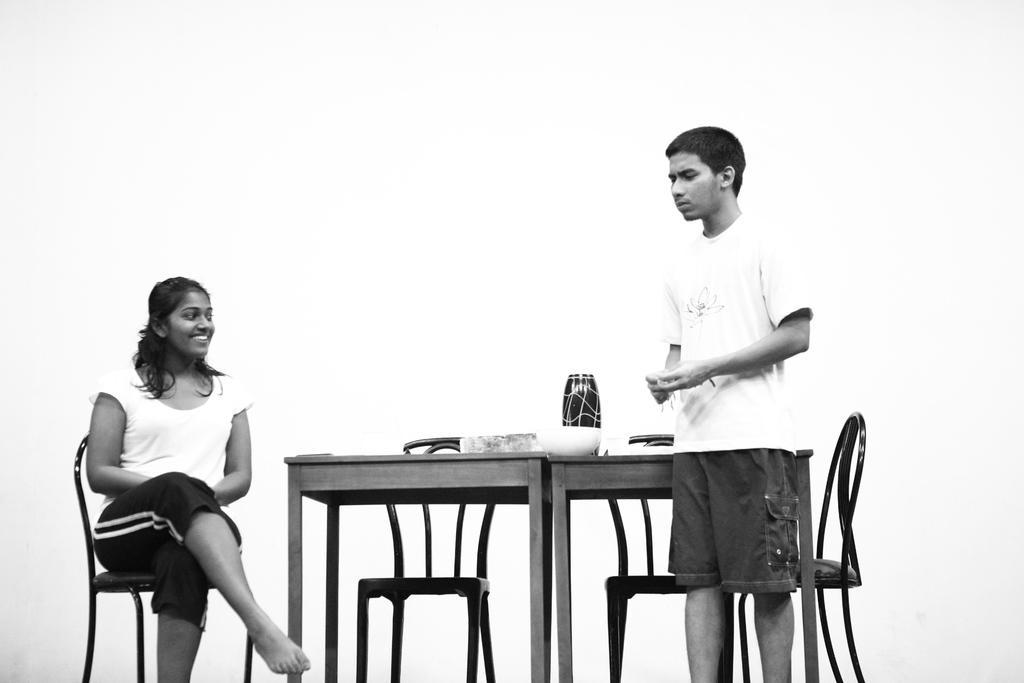Could you give a brief overview of what you see in this image? In this picture we can see one person is standing and talking towards the opposite setting women on the chair there are some chairs and table, on the table we have a bowel bottle are been placed. 